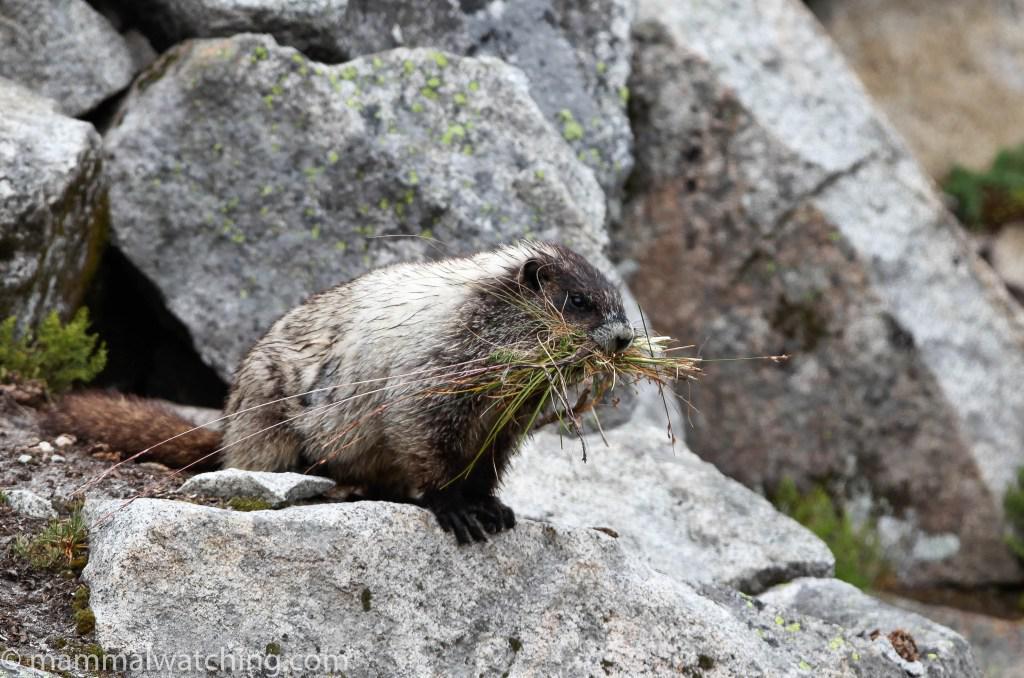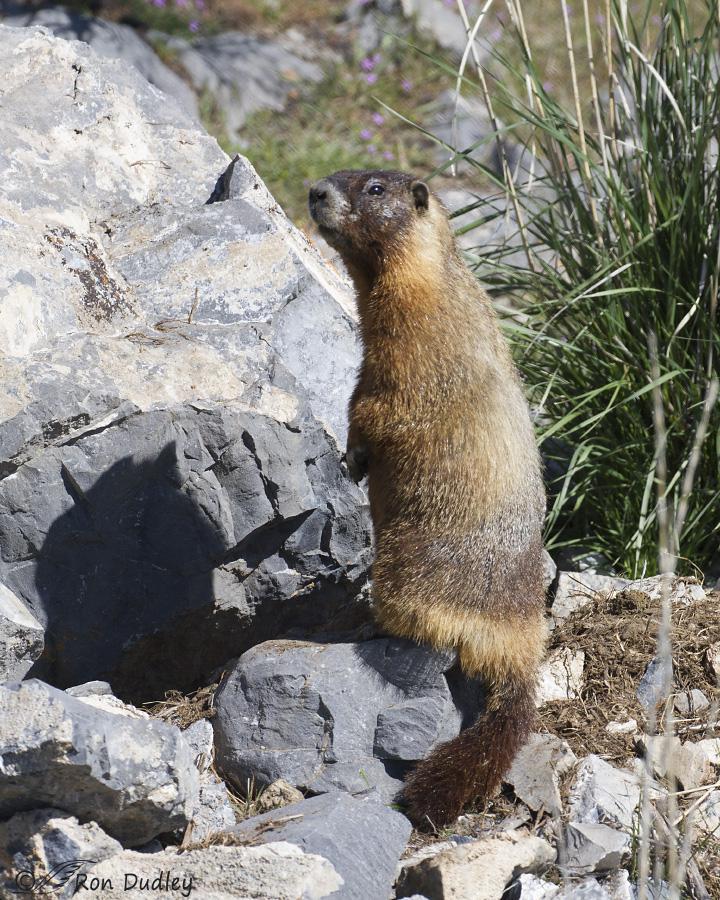The first image is the image on the left, the second image is the image on the right. Given the left and right images, does the statement "At least one of the animals is standing up on its hind legs." hold true? Answer yes or no. Yes. The first image is the image on the left, the second image is the image on the right. Examine the images to the left and right. Is the description "There is signal tan and brown animal sitting on a rock looking left." accurate? Answer yes or no. Yes. The first image is the image on the left, the second image is the image on the right. Given the left and right images, does the statement "There are only two animals, and they are facing opposite directions." hold true? Answer yes or no. Yes. The first image is the image on the left, the second image is the image on the right. Assess this claim about the two images: "Right image shows a rightward-facing marmot perched on a rock with its tail visible.". Correct or not? Answer yes or no. No. 